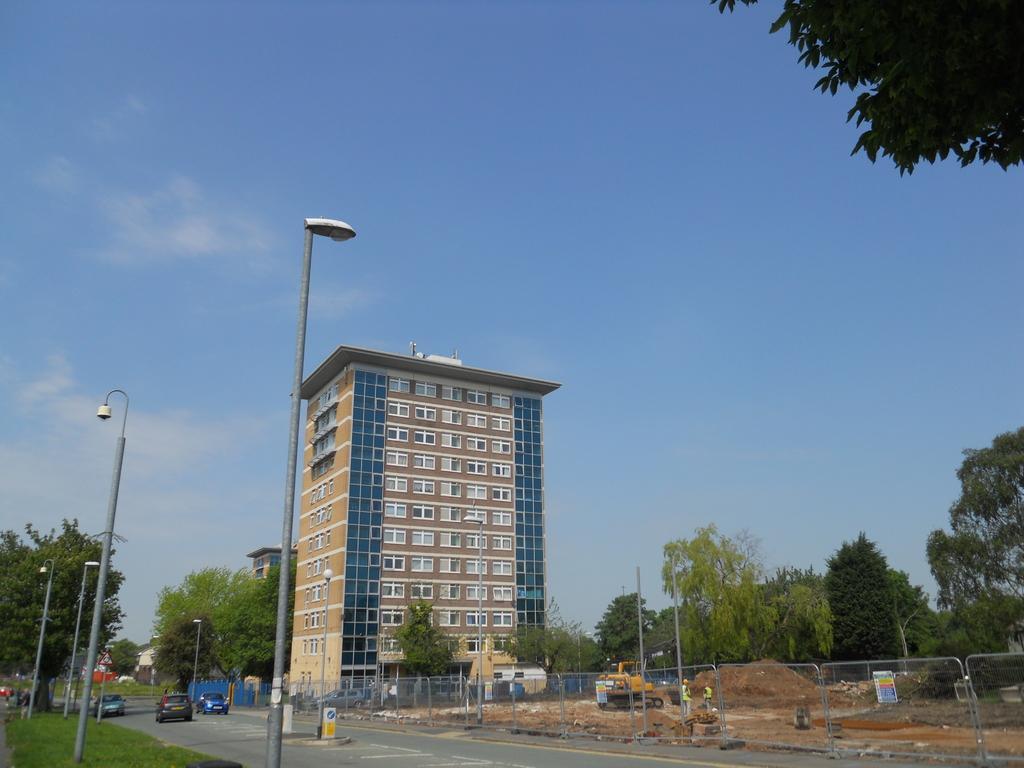Could you give a brief overview of what you see in this image? In the picture I can see light poles, vehicles moving on the road, I can see grass, fence, sand, bulldozer, trees, tower building and the sky in the background. 